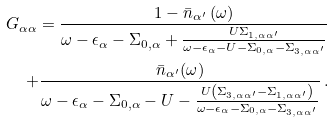<formula> <loc_0><loc_0><loc_500><loc_500>G _ { \alpha \alpha } = \frac { 1 - \bar { n } _ { { \alpha } ^ { \prime } } \left ( \omega \right ) } { \omega - \epsilon _ { \alpha } - { \Sigma } _ { 0 , \alpha } + \frac { U { \Sigma } _ { 1 , \alpha { \alpha } ^ { \prime } } } { \omega - \epsilon _ { \alpha } - U - { \Sigma } _ { 0 , \alpha } - { \Sigma } _ { 3 , \alpha { \alpha } ^ { \prime } } } } \\ + \frac { \bar { n } _ { { \alpha } ^ { \prime } } ( \omega ) } { \omega - \epsilon _ { \alpha } - { \Sigma } _ { 0 , \alpha } - U - \frac { U \left ( { \Sigma } _ { 3 , { \alpha } { \alpha } ^ { \prime } } - { \Sigma } _ { 1 , { \alpha } { \alpha } ^ { \prime } } \right ) } { \omega - \epsilon _ { \alpha } - { \Sigma } _ { 0 , \alpha } - { \Sigma } _ { 3 , \alpha { \alpha } ^ { \prime } } } } \, .</formula> 